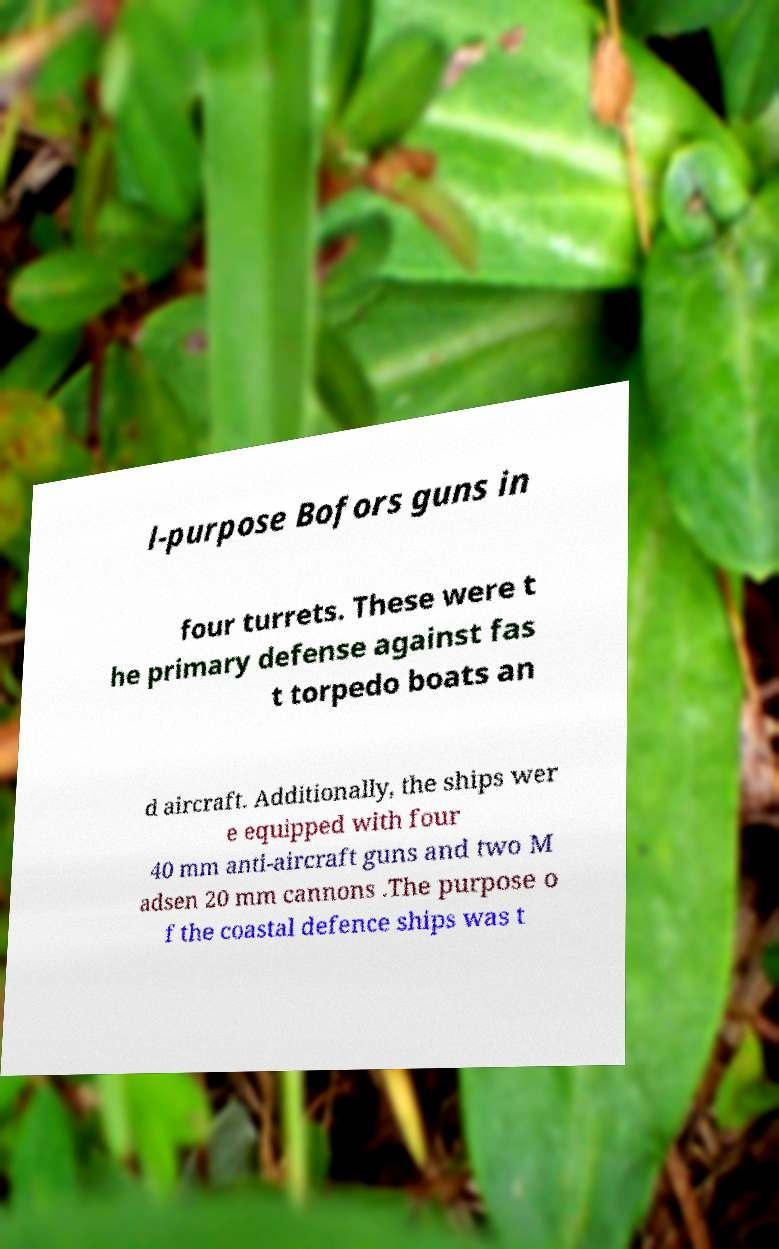I need the written content from this picture converted into text. Can you do that? l-purpose Bofors guns in four turrets. These were t he primary defense against fas t torpedo boats an d aircraft. Additionally, the ships wer e equipped with four 40 mm anti-aircraft guns and two M adsen 20 mm cannons .The purpose o f the coastal defence ships was t 